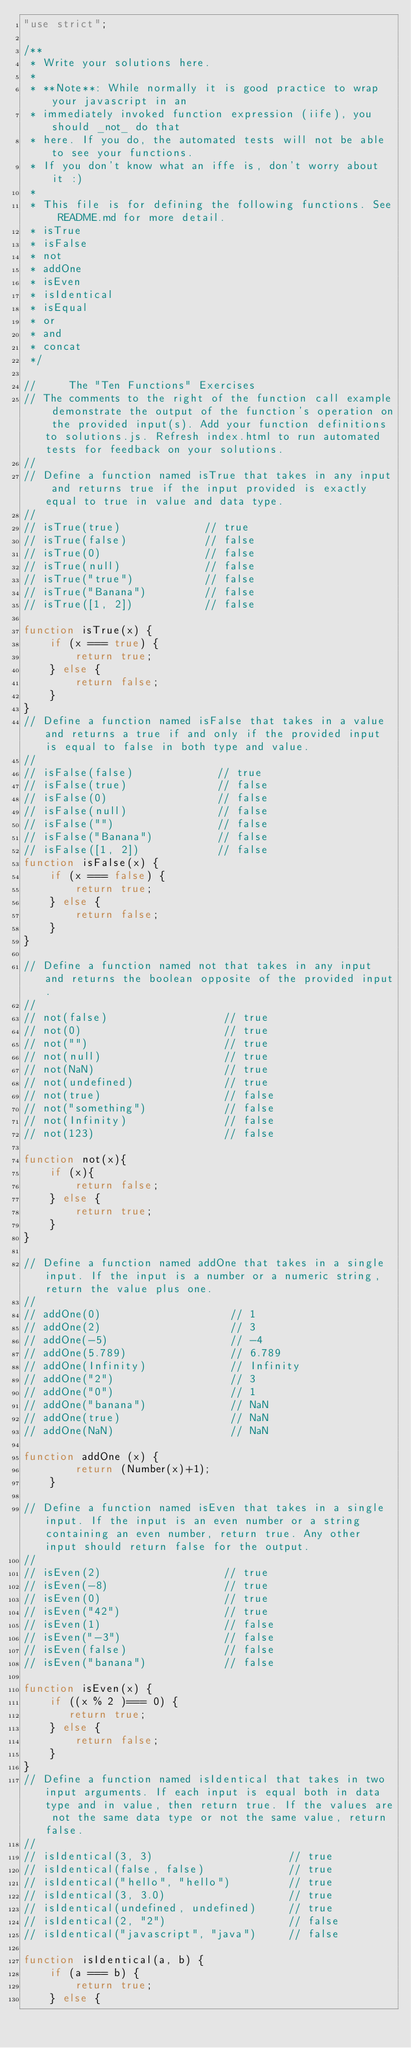Convert code to text. <code><loc_0><loc_0><loc_500><loc_500><_JavaScript_>"use strict";

/**
 * Write your solutions here.
 *
 * **Note**: While normally it is good practice to wrap your javascript in an
 * immediately invoked function expression (iife), you should _not_ do that
 * here. If you do, the automated tests will not be able to see your functions.
 * If you don't know what an iffe is, don't worry about it :)
 *
 * This file is for defining the following functions. See README.md for more detail.
 * isTrue
 * isFalse
 * not
 * addOne
 * isEven
 * isIdentical
 * isEqual
 * or
 * and
 * concat
 */

//     The "Ten Functions" Exercises
// The comments to the right of the function call example demonstrate the output of the function's operation on the provided input(s). Add your function definitions to solutions.js. Refresh index.html to run automated tests for feedback on your solutions.
//
// Define a function named isTrue that takes in any input and returns true if the input provided is exactly equal to true in value and data type.
//
// isTrue(true)             // true
// isTrue(false)            // false
// isTrue(0)                // false
// isTrue(null)             // false
// isTrue("true")           // false
// isTrue("Banana")         // false
// isTrue([1, 2])           // false

function isTrue(x) {
    if (x === true) {
        return true;
    } else {
        return false;
    }
}
// Define a function named isFalse that takes in a value and returns a true if and only if the provided input is equal to false in both type and value.
//
// isFalse(false)             // true
// isFalse(true)              // false
// isFalse(0)                 // false
// isFalse(null)              // false
// isFalse("")                // false
// isFalse("Banana")          // false
// isFalse([1, 2])            // false
function isFalse(x) {
    if (x === false) {
        return true;
    } else {
        return false;
    }
}

// Define a function named not that takes in any input and returns the boolean opposite of the provided input.
//
// not(false)                  // true
// not(0)                      // true
// not("")                     // true
// not(null)                   // true
// not(NaN)                    // true
// not(undefined)              // true
// not(true)                   // false
// not("something")            // false
// not(Infinity)               // false
// not(123)                    // false

function not(x){
    if (x){
        return false;
    } else {
        return true;
    }
}

// Define a function named addOne that takes in a single input. If the input is a number or a numeric string, return the value plus one.
//
// addOne(0)                    // 1
// addOne(2)                    // 3
// addOne(-5)                   // -4
// addOne(5.789)                // 6.789
// addOne(Infinity)             // Infinity
// addOne("2")                  // 3
// addOne("0")                  // 1
// addOne("banana")             // NaN
// addOne(true)                 // NaN
// addOne(NaN)                  // NaN

function addOne (x) {
        return (Number(x)+1);
    }

// Define a function named isEven that takes in a single input. If the input is an even number or a string containing an even number, return true. Any other input should return false for the output.
//
// isEven(2)                   // true
// isEven(-8)                  // true
// isEven(0)                   // true
// isEven("42")                // true
// isEven(1)                   // false
// isEven("-3")                // false
// isEven(false)               // false
// isEven("banana")            // false

function isEven(x) {
    if ((x % 2 )=== 0) {
       return true;
    } else {
        return false;
    }
}
// Define a function named isIdentical that takes in two input arguments. If each input is equal both in data type and in value, then return true. If the values are not the same data type or not the same value, return false.
//
// isIdentical(3, 3)                     // true
// isIdentical(false, false)             // true
// isIdentical("hello", "hello")         // true
// isIdentical(3, 3.0)                   // true
// isIdentical(undefined, undefined)     // true
// isIdentical(2, "2")                   // false
// isIdentical("javascript", "java")     // false

function isIdentical(a, b) {
    if (a === b) {
        return true;
    } else {</code> 